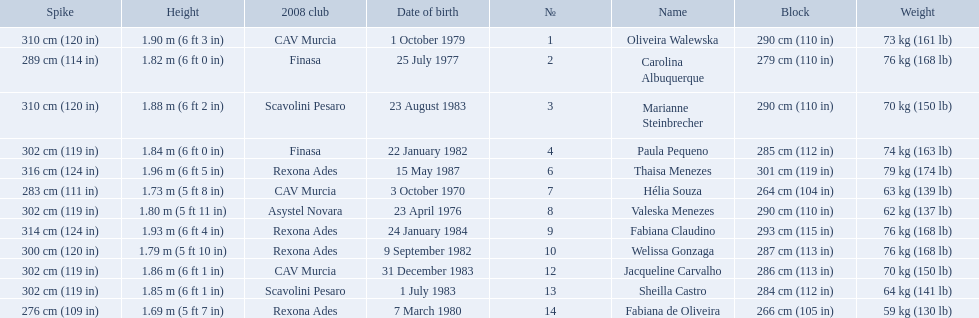How much does fabiana de oliveira weigh? 76 kg (168 lb). How much does helia souza weigh? 63 kg (139 lb). How much does sheilla castro weigh? 64 kg (141 lb). Whose weight did the original question asker incorrectly believe to be the heaviest (they are the second heaviest)? Sheilla Castro. 